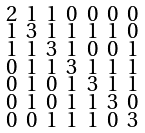Convert formula to latex. <formula><loc_0><loc_0><loc_500><loc_500>\begin{smallmatrix} 2 & 1 & 1 & 0 & 0 & 0 & 0 \\ 1 & 3 & 1 & 1 & 1 & 1 & 0 \\ 1 & 1 & 3 & 1 & 0 & 0 & 1 \\ 0 & 1 & 1 & 3 & 1 & 1 & 1 \\ 0 & 1 & 0 & 1 & 3 & 1 & 1 \\ 0 & 1 & 0 & 1 & 1 & 3 & 0 \\ 0 & 0 & 1 & 1 & 1 & 0 & 3 \end{smallmatrix}</formula> 